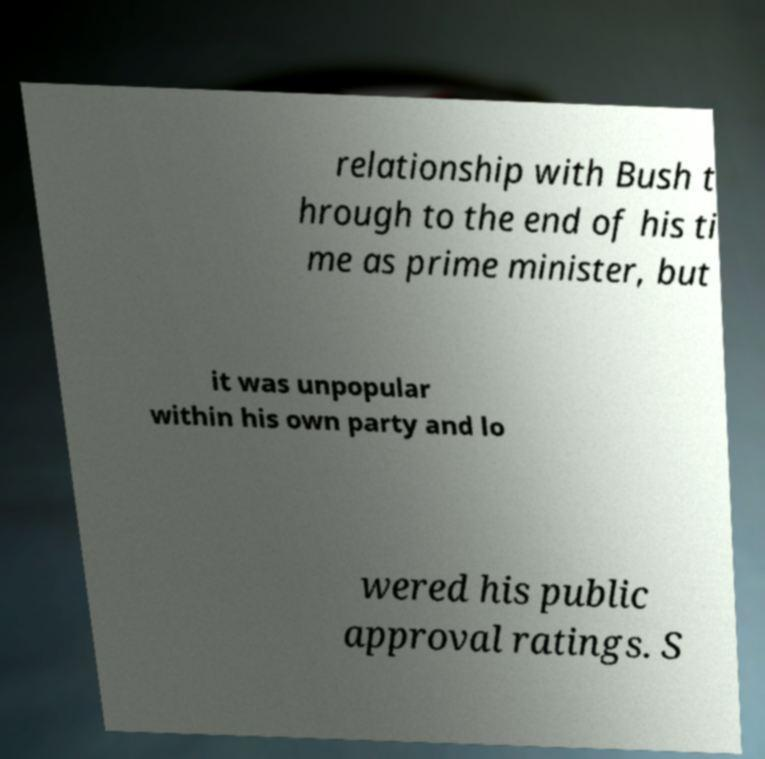Please identify and transcribe the text found in this image. relationship with Bush t hrough to the end of his ti me as prime minister, but it was unpopular within his own party and lo wered his public approval ratings. S 